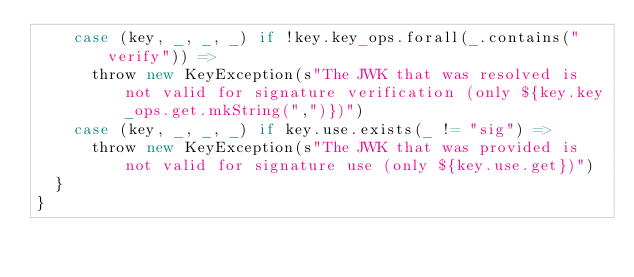<code> <loc_0><loc_0><loc_500><loc_500><_Scala_>    case (key, _, _, _) if !key.key_ops.forall(_.contains("verify")) =>
      throw new KeyException(s"The JWK that was resolved is not valid for signature verification (only ${key.key_ops.get.mkString(",")})")
    case (key, _, _, _) if key.use.exists(_ != "sig") =>
      throw new KeyException(s"The JWK that was provided is not valid for signature use (only ${key.use.get})")
  }
}
</code> 